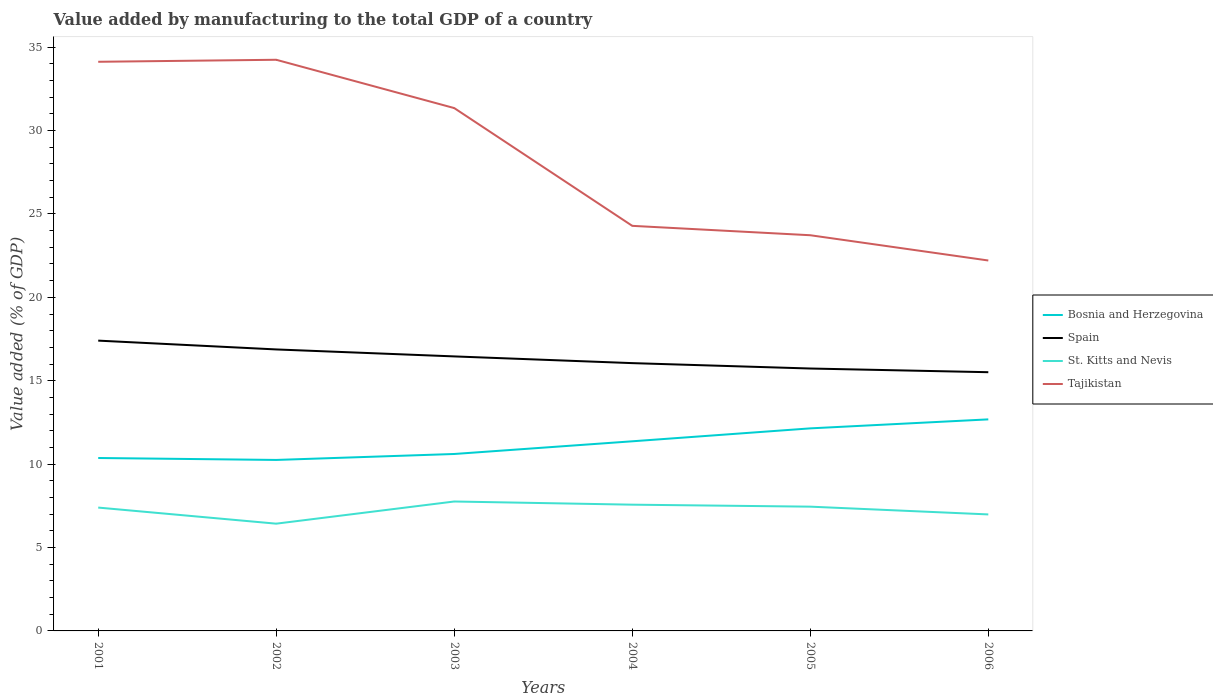Does the line corresponding to Bosnia and Herzegovina intersect with the line corresponding to St. Kitts and Nevis?
Ensure brevity in your answer.  No. Across all years, what is the maximum value added by manufacturing to the total GDP in Tajikistan?
Provide a succinct answer. 22.21. In which year was the value added by manufacturing to the total GDP in Spain maximum?
Offer a very short reply. 2006. What is the total value added by manufacturing to the total GDP in St. Kitts and Nevis in the graph?
Provide a succinct answer. 0.77. What is the difference between the highest and the second highest value added by manufacturing to the total GDP in Bosnia and Herzegovina?
Offer a terse response. 2.43. How many lines are there?
Your answer should be compact. 4. How many years are there in the graph?
Give a very brief answer. 6. Does the graph contain grids?
Offer a terse response. No. How many legend labels are there?
Provide a short and direct response. 4. What is the title of the graph?
Offer a very short reply. Value added by manufacturing to the total GDP of a country. What is the label or title of the Y-axis?
Your response must be concise. Value added (% of GDP). What is the Value added (% of GDP) of Bosnia and Herzegovina in 2001?
Offer a very short reply. 10.37. What is the Value added (% of GDP) in Spain in 2001?
Give a very brief answer. 17.41. What is the Value added (% of GDP) of St. Kitts and Nevis in 2001?
Provide a succinct answer. 7.4. What is the Value added (% of GDP) of Tajikistan in 2001?
Provide a succinct answer. 34.12. What is the Value added (% of GDP) of Bosnia and Herzegovina in 2002?
Offer a very short reply. 10.25. What is the Value added (% of GDP) in Spain in 2002?
Ensure brevity in your answer.  16.88. What is the Value added (% of GDP) in St. Kitts and Nevis in 2002?
Give a very brief answer. 6.43. What is the Value added (% of GDP) of Tajikistan in 2002?
Ensure brevity in your answer.  34.24. What is the Value added (% of GDP) of Bosnia and Herzegovina in 2003?
Offer a terse response. 10.61. What is the Value added (% of GDP) in Spain in 2003?
Give a very brief answer. 16.46. What is the Value added (% of GDP) in St. Kitts and Nevis in 2003?
Ensure brevity in your answer.  7.76. What is the Value added (% of GDP) in Tajikistan in 2003?
Give a very brief answer. 31.35. What is the Value added (% of GDP) of Bosnia and Herzegovina in 2004?
Offer a terse response. 11.37. What is the Value added (% of GDP) of Spain in 2004?
Provide a succinct answer. 16.06. What is the Value added (% of GDP) of St. Kitts and Nevis in 2004?
Give a very brief answer. 7.57. What is the Value added (% of GDP) of Tajikistan in 2004?
Offer a very short reply. 24.29. What is the Value added (% of GDP) in Bosnia and Herzegovina in 2005?
Offer a very short reply. 12.14. What is the Value added (% of GDP) in Spain in 2005?
Offer a terse response. 15.73. What is the Value added (% of GDP) in St. Kitts and Nevis in 2005?
Provide a succinct answer. 7.45. What is the Value added (% of GDP) in Tajikistan in 2005?
Provide a short and direct response. 23.72. What is the Value added (% of GDP) in Bosnia and Herzegovina in 2006?
Your answer should be compact. 12.68. What is the Value added (% of GDP) of Spain in 2006?
Offer a terse response. 15.51. What is the Value added (% of GDP) of St. Kitts and Nevis in 2006?
Ensure brevity in your answer.  6.99. What is the Value added (% of GDP) of Tajikistan in 2006?
Make the answer very short. 22.21. Across all years, what is the maximum Value added (% of GDP) of Bosnia and Herzegovina?
Offer a terse response. 12.68. Across all years, what is the maximum Value added (% of GDP) of Spain?
Your response must be concise. 17.41. Across all years, what is the maximum Value added (% of GDP) in St. Kitts and Nevis?
Provide a succinct answer. 7.76. Across all years, what is the maximum Value added (% of GDP) of Tajikistan?
Offer a very short reply. 34.24. Across all years, what is the minimum Value added (% of GDP) of Bosnia and Herzegovina?
Provide a succinct answer. 10.25. Across all years, what is the minimum Value added (% of GDP) in Spain?
Your answer should be compact. 15.51. Across all years, what is the minimum Value added (% of GDP) of St. Kitts and Nevis?
Make the answer very short. 6.43. Across all years, what is the minimum Value added (% of GDP) of Tajikistan?
Your answer should be compact. 22.21. What is the total Value added (% of GDP) in Bosnia and Herzegovina in the graph?
Provide a short and direct response. 67.42. What is the total Value added (% of GDP) in Spain in the graph?
Keep it short and to the point. 98.04. What is the total Value added (% of GDP) in St. Kitts and Nevis in the graph?
Give a very brief answer. 43.59. What is the total Value added (% of GDP) of Tajikistan in the graph?
Give a very brief answer. 169.93. What is the difference between the Value added (% of GDP) in Bosnia and Herzegovina in 2001 and that in 2002?
Your answer should be compact. 0.12. What is the difference between the Value added (% of GDP) of Spain in 2001 and that in 2002?
Provide a short and direct response. 0.53. What is the difference between the Value added (% of GDP) in St. Kitts and Nevis in 2001 and that in 2002?
Ensure brevity in your answer.  0.96. What is the difference between the Value added (% of GDP) of Tajikistan in 2001 and that in 2002?
Offer a terse response. -0.12. What is the difference between the Value added (% of GDP) in Bosnia and Herzegovina in 2001 and that in 2003?
Ensure brevity in your answer.  -0.24. What is the difference between the Value added (% of GDP) of Spain in 2001 and that in 2003?
Your answer should be very brief. 0.95. What is the difference between the Value added (% of GDP) of St. Kitts and Nevis in 2001 and that in 2003?
Your answer should be very brief. -0.36. What is the difference between the Value added (% of GDP) in Tajikistan in 2001 and that in 2003?
Offer a terse response. 2.78. What is the difference between the Value added (% of GDP) of Bosnia and Herzegovina in 2001 and that in 2004?
Offer a very short reply. -1. What is the difference between the Value added (% of GDP) of Spain in 2001 and that in 2004?
Your answer should be compact. 1.35. What is the difference between the Value added (% of GDP) in St. Kitts and Nevis in 2001 and that in 2004?
Your answer should be compact. -0.17. What is the difference between the Value added (% of GDP) of Tajikistan in 2001 and that in 2004?
Keep it short and to the point. 9.84. What is the difference between the Value added (% of GDP) of Bosnia and Herzegovina in 2001 and that in 2005?
Your answer should be very brief. -1.78. What is the difference between the Value added (% of GDP) of Spain in 2001 and that in 2005?
Your response must be concise. 1.67. What is the difference between the Value added (% of GDP) of St. Kitts and Nevis in 2001 and that in 2005?
Your answer should be compact. -0.06. What is the difference between the Value added (% of GDP) in Tajikistan in 2001 and that in 2005?
Offer a terse response. 10.4. What is the difference between the Value added (% of GDP) of Bosnia and Herzegovina in 2001 and that in 2006?
Ensure brevity in your answer.  -2.32. What is the difference between the Value added (% of GDP) in Spain in 2001 and that in 2006?
Offer a terse response. 1.89. What is the difference between the Value added (% of GDP) in St. Kitts and Nevis in 2001 and that in 2006?
Offer a terse response. 0.41. What is the difference between the Value added (% of GDP) in Tajikistan in 2001 and that in 2006?
Offer a terse response. 11.91. What is the difference between the Value added (% of GDP) in Bosnia and Herzegovina in 2002 and that in 2003?
Your response must be concise. -0.36. What is the difference between the Value added (% of GDP) in Spain in 2002 and that in 2003?
Your answer should be very brief. 0.42. What is the difference between the Value added (% of GDP) in St. Kitts and Nevis in 2002 and that in 2003?
Offer a very short reply. -1.33. What is the difference between the Value added (% of GDP) in Tajikistan in 2002 and that in 2003?
Your answer should be very brief. 2.9. What is the difference between the Value added (% of GDP) in Bosnia and Herzegovina in 2002 and that in 2004?
Offer a very short reply. -1.12. What is the difference between the Value added (% of GDP) in Spain in 2002 and that in 2004?
Your response must be concise. 0.82. What is the difference between the Value added (% of GDP) in St. Kitts and Nevis in 2002 and that in 2004?
Make the answer very short. -1.14. What is the difference between the Value added (% of GDP) of Tajikistan in 2002 and that in 2004?
Offer a very short reply. 9.96. What is the difference between the Value added (% of GDP) of Bosnia and Herzegovina in 2002 and that in 2005?
Keep it short and to the point. -1.89. What is the difference between the Value added (% of GDP) of Spain in 2002 and that in 2005?
Your answer should be compact. 1.14. What is the difference between the Value added (% of GDP) in St. Kitts and Nevis in 2002 and that in 2005?
Offer a terse response. -1.02. What is the difference between the Value added (% of GDP) in Tajikistan in 2002 and that in 2005?
Make the answer very short. 10.52. What is the difference between the Value added (% of GDP) in Bosnia and Herzegovina in 2002 and that in 2006?
Offer a terse response. -2.43. What is the difference between the Value added (% of GDP) of Spain in 2002 and that in 2006?
Offer a terse response. 1.36. What is the difference between the Value added (% of GDP) in St. Kitts and Nevis in 2002 and that in 2006?
Ensure brevity in your answer.  -0.55. What is the difference between the Value added (% of GDP) of Tajikistan in 2002 and that in 2006?
Offer a very short reply. 12.04. What is the difference between the Value added (% of GDP) of Bosnia and Herzegovina in 2003 and that in 2004?
Your response must be concise. -0.76. What is the difference between the Value added (% of GDP) in Spain in 2003 and that in 2004?
Provide a short and direct response. 0.4. What is the difference between the Value added (% of GDP) of St. Kitts and Nevis in 2003 and that in 2004?
Give a very brief answer. 0.19. What is the difference between the Value added (% of GDP) in Tajikistan in 2003 and that in 2004?
Provide a succinct answer. 7.06. What is the difference between the Value added (% of GDP) in Bosnia and Herzegovina in 2003 and that in 2005?
Your answer should be compact. -1.54. What is the difference between the Value added (% of GDP) of Spain in 2003 and that in 2005?
Make the answer very short. 0.73. What is the difference between the Value added (% of GDP) in St. Kitts and Nevis in 2003 and that in 2005?
Offer a very short reply. 0.31. What is the difference between the Value added (% of GDP) of Tajikistan in 2003 and that in 2005?
Your response must be concise. 7.62. What is the difference between the Value added (% of GDP) of Bosnia and Herzegovina in 2003 and that in 2006?
Keep it short and to the point. -2.07. What is the difference between the Value added (% of GDP) in Spain in 2003 and that in 2006?
Keep it short and to the point. 0.95. What is the difference between the Value added (% of GDP) in St. Kitts and Nevis in 2003 and that in 2006?
Offer a terse response. 0.77. What is the difference between the Value added (% of GDP) in Tajikistan in 2003 and that in 2006?
Offer a terse response. 9.14. What is the difference between the Value added (% of GDP) in Bosnia and Herzegovina in 2004 and that in 2005?
Offer a very short reply. -0.78. What is the difference between the Value added (% of GDP) in Spain in 2004 and that in 2005?
Your answer should be very brief. 0.32. What is the difference between the Value added (% of GDP) of St. Kitts and Nevis in 2004 and that in 2005?
Ensure brevity in your answer.  0.12. What is the difference between the Value added (% of GDP) in Tajikistan in 2004 and that in 2005?
Offer a terse response. 0.56. What is the difference between the Value added (% of GDP) in Bosnia and Herzegovina in 2004 and that in 2006?
Provide a succinct answer. -1.31. What is the difference between the Value added (% of GDP) in Spain in 2004 and that in 2006?
Your answer should be compact. 0.54. What is the difference between the Value added (% of GDP) of St. Kitts and Nevis in 2004 and that in 2006?
Make the answer very short. 0.58. What is the difference between the Value added (% of GDP) of Tajikistan in 2004 and that in 2006?
Make the answer very short. 2.08. What is the difference between the Value added (% of GDP) in Bosnia and Herzegovina in 2005 and that in 2006?
Make the answer very short. -0.54. What is the difference between the Value added (% of GDP) in Spain in 2005 and that in 2006?
Your response must be concise. 0.22. What is the difference between the Value added (% of GDP) of St. Kitts and Nevis in 2005 and that in 2006?
Your answer should be very brief. 0.47. What is the difference between the Value added (% of GDP) in Tajikistan in 2005 and that in 2006?
Offer a terse response. 1.51. What is the difference between the Value added (% of GDP) in Bosnia and Herzegovina in 2001 and the Value added (% of GDP) in Spain in 2002?
Ensure brevity in your answer.  -6.51. What is the difference between the Value added (% of GDP) of Bosnia and Herzegovina in 2001 and the Value added (% of GDP) of St. Kitts and Nevis in 2002?
Your answer should be compact. 3.94. What is the difference between the Value added (% of GDP) of Bosnia and Herzegovina in 2001 and the Value added (% of GDP) of Tajikistan in 2002?
Provide a short and direct response. -23.88. What is the difference between the Value added (% of GDP) of Spain in 2001 and the Value added (% of GDP) of St. Kitts and Nevis in 2002?
Your response must be concise. 10.98. What is the difference between the Value added (% of GDP) of Spain in 2001 and the Value added (% of GDP) of Tajikistan in 2002?
Make the answer very short. -16.84. What is the difference between the Value added (% of GDP) of St. Kitts and Nevis in 2001 and the Value added (% of GDP) of Tajikistan in 2002?
Your response must be concise. -26.85. What is the difference between the Value added (% of GDP) in Bosnia and Herzegovina in 2001 and the Value added (% of GDP) in Spain in 2003?
Your answer should be compact. -6.09. What is the difference between the Value added (% of GDP) in Bosnia and Herzegovina in 2001 and the Value added (% of GDP) in St. Kitts and Nevis in 2003?
Your answer should be compact. 2.61. What is the difference between the Value added (% of GDP) of Bosnia and Herzegovina in 2001 and the Value added (% of GDP) of Tajikistan in 2003?
Offer a very short reply. -20.98. What is the difference between the Value added (% of GDP) of Spain in 2001 and the Value added (% of GDP) of St. Kitts and Nevis in 2003?
Keep it short and to the point. 9.65. What is the difference between the Value added (% of GDP) of Spain in 2001 and the Value added (% of GDP) of Tajikistan in 2003?
Provide a succinct answer. -13.94. What is the difference between the Value added (% of GDP) in St. Kitts and Nevis in 2001 and the Value added (% of GDP) in Tajikistan in 2003?
Keep it short and to the point. -23.95. What is the difference between the Value added (% of GDP) in Bosnia and Herzegovina in 2001 and the Value added (% of GDP) in Spain in 2004?
Provide a short and direct response. -5.69. What is the difference between the Value added (% of GDP) in Bosnia and Herzegovina in 2001 and the Value added (% of GDP) in St. Kitts and Nevis in 2004?
Offer a very short reply. 2.8. What is the difference between the Value added (% of GDP) of Bosnia and Herzegovina in 2001 and the Value added (% of GDP) of Tajikistan in 2004?
Provide a short and direct response. -13.92. What is the difference between the Value added (% of GDP) in Spain in 2001 and the Value added (% of GDP) in St. Kitts and Nevis in 2004?
Provide a succinct answer. 9.84. What is the difference between the Value added (% of GDP) of Spain in 2001 and the Value added (% of GDP) of Tajikistan in 2004?
Give a very brief answer. -6.88. What is the difference between the Value added (% of GDP) in St. Kitts and Nevis in 2001 and the Value added (% of GDP) in Tajikistan in 2004?
Your response must be concise. -16.89. What is the difference between the Value added (% of GDP) in Bosnia and Herzegovina in 2001 and the Value added (% of GDP) in Spain in 2005?
Offer a very short reply. -5.36. What is the difference between the Value added (% of GDP) in Bosnia and Herzegovina in 2001 and the Value added (% of GDP) in St. Kitts and Nevis in 2005?
Offer a very short reply. 2.92. What is the difference between the Value added (% of GDP) in Bosnia and Herzegovina in 2001 and the Value added (% of GDP) in Tajikistan in 2005?
Your answer should be compact. -13.36. What is the difference between the Value added (% of GDP) in Spain in 2001 and the Value added (% of GDP) in St. Kitts and Nevis in 2005?
Your response must be concise. 9.96. What is the difference between the Value added (% of GDP) of Spain in 2001 and the Value added (% of GDP) of Tajikistan in 2005?
Give a very brief answer. -6.32. What is the difference between the Value added (% of GDP) in St. Kitts and Nevis in 2001 and the Value added (% of GDP) in Tajikistan in 2005?
Provide a short and direct response. -16.33. What is the difference between the Value added (% of GDP) of Bosnia and Herzegovina in 2001 and the Value added (% of GDP) of Spain in 2006?
Offer a terse response. -5.14. What is the difference between the Value added (% of GDP) of Bosnia and Herzegovina in 2001 and the Value added (% of GDP) of St. Kitts and Nevis in 2006?
Provide a succinct answer. 3.38. What is the difference between the Value added (% of GDP) in Bosnia and Herzegovina in 2001 and the Value added (% of GDP) in Tajikistan in 2006?
Provide a succinct answer. -11.84. What is the difference between the Value added (% of GDP) in Spain in 2001 and the Value added (% of GDP) in St. Kitts and Nevis in 2006?
Your response must be concise. 10.42. What is the difference between the Value added (% of GDP) in Spain in 2001 and the Value added (% of GDP) in Tajikistan in 2006?
Your answer should be compact. -4.8. What is the difference between the Value added (% of GDP) in St. Kitts and Nevis in 2001 and the Value added (% of GDP) in Tajikistan in 2006?
Offer a terse response. -14.81. What is the difference between the Value added (% of GDP) in Bosnia and Herzegovina in 2002 and the Value added (% of GDP) in Spain in 2003?
Ensure brevity in your answer.  -6.21. What is the difference between the Value added (% of GDP) in Bosnia and Herzegovina in 2002 and the Value added (% of GDP) in St. Kitts and Nevis in 2003?
Provide a succinct answer. 2.49. What is the difference between the Value added (% of GDP) of Bosnia and Herzegovina in 2002 and the Value added (% of GDP) of Tajikistan in 2003?
Your response must be concise. -21.1. What is the difference between the Value added (% of GDP) of Spain in 2002 and the Value added (% of GDP) of St. Kitts and Nevis in 2003?
Provide a succinct answer. 9.12. What is the difference between the Value added (% of GDP) of Spain in 2002 and the Value added (% of GDP) of Tajikistan in 2003?
Your response must be concise. -14.47. What is the difference between the Value added (% of GDP) of St. Kitts and Nevis in 2002 and the Value added (% of GDP) of Tajikistan in 2003?
Offer a very short reply. -24.92. What is the difference between the Value added (% of GDP) of Bosnia and Herzegovina in 2002 and the Value added (% of GDP) of Spain in 2004?
Provide a short and direct response. -5.8. What is the difference between the Value added (% of GDP) of Bosnia and Herzegovina in 2002 and the Value added (% of GDP) of St. Kitts and Nevis in 2004?
Offer a very short reply. 2.68. What is the difference between the Value added (% of GDP) in Bosnia and Herzegovina in 2002 and the Value added (% of GDP) in Tajikistan in 2004?
Offer a terse response. -14.04. What is the difference between the Value added (% of GDP) of Spain in 2002 and the Value added (% of GDP) of St. Kitts and Nevis in 2004?
Keep it short and to the point. 9.31. What is the difference between the Value added (% of GDP) of Spain in 2002 and the Value added (% of GDP) of Tajikistan in 2004?
Offer a very short reply. -7.41. What is the difference between the Value added (% of GDP) of St. Kitts and Nevis in 2002 and the Value added (% of GDP) of Tajikistan in 2004?
Provide a succinct answer. -17.86. What is the difference between the Value added (% of GDP) of Bosnia and Herzegovina in 2002 and the Value added (% of GDP) of Spain in 2005?
Give a very brief answer. -5.48. What is the difference between the Value added (% of GDP) of Bosnia and Herzegovina in 2002 and the Value added (% of GDP) of St. Kitts and Nevis in 2005?
Your answer should be very brief. 2.8. What is the difference between the Value added (% of GDP) in Bosnia and Herzegovina in 2002 and the Value added (% of GDP) in Tajikistan in 2005?
Provide a short and direct response. -13.47. What is the difference between the Value added (% of GDP) of Spain in 2002 and the Value added (% of GDP) of St. Kitts and Nevis in 2005?
Ensure brevity in your answer.  9.43. What is the difference between the Value added (% of GDP) in Spain in 2002 and the Value added (% of GDP) in Tajikistan in 2005?
Provide a short and direct response. -6.85. What is the difference between the Value added (% of GDP) in St. Kitts and Nevis in 2002 and the Value added (% of GDP) in Tajikistan in 2005?
Offer a very short reply. -17.29. What is the difference between the Value added (% of GDP) in Bosnia and Herzegovina in 2002 and the Value added (% of GDP) in Spain in 2006?
Your response must be concise. -5.26. What is the difference between the Value added (% of GDP) of Bosnia and Herzegovina in 2002 and the Value added (% of GDP) of St. Kitts and Nevis in 2006?
Your answer should be compact. 3.27. What is the difference between the Value added (% of GDP) in Bosnia and Herzegovina in 2002 and the Value added (% of GDP) in Tajikistan in 2006?
Your answer should be very brief. -11.96. What is the difference between the Value added (% of GDP) in Spain in 2002 and the Value added (% of GDP) in St. Kitts and Nevis in 2006?
Give a very brief answer. 9.89. What is the difference between the Value added (% of GDP) of Spain in 2002 and the Value added (% of GDP) of Tajikistan in 2006?
Give a very brief answer. -5.33. What is the difference between the Value added (% of GDP) of St. Kitts and Nevis in 2002 and the Value added (% of GDP) of Tajikistan in 2006?
Your answer should be very brief. -15.78. What is the difference between the Value added (% of GDP) in Bosnia and Herzegovina in 2003 and the Value added (% of GDP) in Spain in 2004?
Your answer should be compact. -5.45. What is the difference between the Value added (% of GDP) of Bosnia and Herzegovina in 2003 and the Value added (% of GDP) of St. Kitts and Nevis in 2004?
Offer a terse response. 3.04. What is the difference between the Value added (% of GDP) of Bosnia and Herzegovina in 2003 and the Value added (% of GDP) of Tajikistan in 2004?
Keep it short and to the point. -13.68. What is the difference between the Value added (% of GDP) in Spain in 2003 and the Value added (% of GDP) in St. Kitts and Nevis in 2004?
Your response must be concise. 8.89. What is the difference between the Value added (% of GDP) in Spain in 2003 and the Value added (% of GDP) in Tajikistan in 2004?
Keep it short and to the point. -7.83. What is the difference between the Value added (% of GDP) in St. Kitts and Nevis in 2003 and the Value added (% of GDP) in Tajikistan in 2004?
Your answer should be compact. -16.53. What is the difference between the Value added (% of GDP) of Bosnia and Herzegovina in 2003 and the Value added (% of GDP) of Spain in 2005?
Your answer should be very brief. -5.12. What is the difference between the Value added (% of GDP) of Bosnia and Herzegovina in 2003 and the Value added (% of GDP) of St. Kitts and Nevis in 2005?
Your answer should be compact. 3.16. What is the difference between the Value added (% of GDP) in Bosnia and Herzegovina in 2003 and the Value added (% of GDP) in Tajikistan in 2005?
Your answer should be very brief. -13.12. What is the difference between the Value added (% of GDP) of Spain in 2003 and the Value added (% of GDP) of St. Kitts and Nevis in 2005?
Provide a succinct answer. 9.01. What is the difference between the Value added (% of GDP) of Spain in 2003 and the Value added (% of GDP) of Tajikistan in 2005?
Ensure brevity in your answer.  -7.27. What is the difference between the Value added (% of GDP) in St. Kitts and Nevis in 2003 and the Value added (% of GDP) in Tajikistan in 2005?
Provide a short and direct response. -15.96. What is the difference between the Value added (% of GDP) of Bosnia and Herzegovina in 2003 and the Value added (% of GDP) of Spain in 2006?
Your answer should be compact. -4.9. What is the difference between the Value added (% of GDP) of Bosnia and Herzegovina in 2003 and the Value added (% of GDP) of St. Kitts and Nevis in 2006?
Offer a terse response. 3.62. What is the difference between the Value added (% of GDP) in Bosnia and Herzegovina in 2003 and the Value added (% of GDP) in Tajikistan in 2006?
Offer a very short reply. -11.6. What is the difference between the Value added (% of GDP) of Spain in 2003 and the Value added (% of GDP) of St. Kitts and Nevis in 2006?
Your response must be concise. 9.47. What is the difference between the Value added (% of GDP) in Spain in 2003 and the Value added (% of GDP) in Tajikistan in 2006?
Offer a very short reply. -5.75. What is the difference between the Value added (% of GDP) of St. Kitts and Nevis in 2003 and the Value added (% of GDP) of Tajikistan in 2006?
Offer a terse response. -14.45. What is the difference between the Value added (% of GDP) of Bosnia and Herzegovina in 2004 and the Value added (% of GDP) of Spain in 2005?
Your answer should be very brief. -4.36. What is the difference between the Value added (% of GDP) in Bosnia and Herzegovina in 2004 and the Value added (% of GDP) in St. Kitts and Nevis in 2005?
Your answer should be compact. 3.92. What is the difference between the Value added (% of GDP) of Bosnia and Herzegovina in 2004 and the Value added (% of GDP) of Tajikistan in 2005?
Keep it short and to the point. -12.35. What is the difference between the Value added (% of GDP) in Spain in 2004 and the Value added (% of GDP) in St. Kitts and Nevis in 2005?
Provide a succinct answer. 8.61. What is the difference between the Value added (% of GDP) in Spain in 2004 and the Value added (% of GDP) in Tajikistan in 2005?
Provide a succinct answer. -7.67. What is the difference between the Value added (% of GDP) of St. Kitts and Nevis in 2004 and the Value added (% of GDP) of Tajikistan in 2005?
Your response must be concise. -16.15. What is the difference between the Value added (% of GDP) in Bosnia and Herzegovina in 2004 and the Value added (% of GDP) in Spain in 2006?
Keep it short and to the point. -4.14. What is the difference between the Value added (% of GDP) of Bosnia and Herzegovina in 2004 and the Value added (% of GDP) of St. Kitts and Nevis in 2006?
Provide a succinct answer. 4.38. What is the difference between the Value added (% of GDP) in Bosnia and Herzegovina in 2004 and the Value added (% of GDP) in Tajikistan in 2006?
Ensure brevity in your answer.  -10.84. What is the difference between the Value added (% of GDP) of Spain in 2004 and the Value added (% of GDP) of St. Kitts and Nevis in 2006?
Your answer should be compact. 9.07. What is the difference between the Value added (% of GDP) of Spain in 2004 and the Value added (% of GDP) of Tajikistan in 2006?
Give a very brief answer. -6.15. What is the difference between the Value added (% of GDP) of St. Kitts and Nevis in 2004 and the Value added (% of GDP) of Tajikistan in 2006?
Offer a very short reply. -14.64. What is the difference between the Value added (% of GDP) of Bosnia and Herzegovina in 2005 and the Value added (% of GDP) of Spain in 2006?
Keep it short and to the point. -3.37. What is the difference between the Value added (% of GDP) in Bosnia and Herzegovina in 2005 and the Value added (% of GDP) in St. Kitts and Nevis in 2006?
Your response must be concise. 5.16. What is the difference between the Value added (% of GDP) in Bosnia and Herzegovina in 2005 and the Value added (% of GDP) in Tajikistan in 2006?
Your answer should be compact. -10.06. What is the difference between the Value added (% of GDP) of Spain in 2005 and the Value added (% of GDP) of St. Kitts and Nevis in 2006?
Make the answer very short. 8.75. What is the difference between the Value added (% of GDP) in Spain in 2005 and the Value added (% of GDP) in Tajikistan in 2006?
Provide a short and direct response. -6.48. What is the difference between the Value added (% of GDP) in St. Kitts and Nevis in 2005 and the Value added (% of GDP) in Tajikistan in 2006?
Your answer should be very brief. -14.76. What is the average Value added (% of GDP) in Bosnia and Herzegovina per year?
Keep it short and to the point. 11.24. What is the average Value added (% of GDP) of Spain per year?
Make the answer very short. 16.34. What is the average Value added (% of GDP) in St. Kitts and Nevis per year?
Your response must be concise. 7.27. What is the average Value added (% of GDP) of Tajikistan per year?
Ensure brevity in your answer.  28.32. In the year 2001, what is the difference between the Value added (% of GDP) of Bosnia and Herzegovina and Value added (% of GDP) of Spain?
Ensure brevity in your answer.  -7.04. In the year 2001, what is the difference between the Value added (% of GDP) in Bosnia and Herzegovina and Value added (% of GDP) in St. Kitts and Nevis?
Offer a very short reply. 2.97. In the year 2001, what is the difference between the Value added (% of GDP) of Bosnia and Herzegovina and Value added (% of GDP) of Tajikistan?
Your answer should be very brief. -23.76. In the year 2001, what is the difference between the Value added (% of GDP) of Spain and Value added (% of GDP) of St. Kitts and Nevis?
Make the answer very short. 10.01. In the year 2001, what is the difference between the Value added (% of GDP) in Spain and Value added (% of GDP) in Tajikistan?
Your answer should be very brief. -16.72. In the year 2001, what is the difference between the Value added (% of GDP) of St. Kitts and Nevis and Value added (% of GDP) of Tajikistan?
Offer a terse response. -26.73. In the year 2002, what is the difference between the Value added (% of GDP) in Bosnia and Herzegovina and Value added (% of GDP) in Spain?
Ensure brevity in your answer.  -6.63. In the year 2002, what is the difference between the Value added (% of GDP) of Bosnia and Herzegovina and Value added (% of GDP) of St. Kitts and Nevis?
Keep it short and to the point. 3.82. In the year 2002, what is the difference between the Value added (% of GDP) in Bosnia and Herzegovina and Value added (% of GDP) in Tajikistan?
Provide a succinct answer. -23.99. In the year 2002, what is the difference between the Value added (% of GDP) of Spain and Value added (% of GDP) of St. Kitts and Nevis?
Provide a short and direct response. 10.45. In the year 2002, what is the difference between the Value added (% of GDP) in Spain and Value added (% of GDP) in Tajikistan?
Ensure brevity in your answer.  -17.37. In the year 2002, what is the difference between the Value added (% of GDP) in St. Kitts and Nevis and Value added (% of GDP) in Tajikistan?
Offer a terse response. -27.81. In the year 2003, what is the difference between the Value added (% of GDP) of Bosnia and Herzegovina and Value added (% of GDP) of Spain?
Provide a succinct answer. -5.85. In the year 2003, what is the difference between the Value added (% of GDP) in Bosnia and Herzegovina and Value added (% of GDP) in St. Kitts and Nevis?
Your response must be concise. 2.85. In the year 2003, what is the difference between the Value added (% of GDP) in Bosnia and Herzegovina and Value added (% of GDP) in Tajikistan?
Your answer should be compact. -20.74. In the year 2003, what is the difference between the Value added (% of GDP) of Spain and Value added (% of GDP) of St. Kitts and Nevis?
Your answer should be very brief. 8.7. In the year 2003, what is the difference between the Value added (% of GDP) of Spain and Value added (% of GDP) of Tajikistan?
Ensure brevity in your answer.  -14.89. In the year 2003, what is the difference between the Value added (% of GDP) in St. Kitts and Nevis and Value added (% of GDP) in Tajikistan?
Provide a short and direct response. -23.59. In the year 2004, what is the difference between the Value added (% of GDP) of Bosnia and Herzegovina and Value added (% of GDP) of Spain?
Offer a terse response. -4.69. In the year 2004, what is the difference between the Value added (% of GDP) in Bosnia and Herzegovina and Value added (% of GDP) in St. Kitts and Nevis?
Your answer should be very brief. 3.8. In the year 2004, what is the difference between the Value added (% of GDP) in Bosnia and Herzegovina and Value added (% of GDP) in Tajikistan?
Offer a very short reply. -12.92. In the year 2004, what is the difference between the Value added (% of GDP) in Spain and Value added (% of GDP) in St. Kitts and Nevis?
Offer a terse response. 8.49. In the year 2004, what is the difference between the Value added (% of GDP) of Spain and Value added (% of GDP) of Tajikistan?
Provide a succinct answer. -8.23. In the year 2004, what is the difference between the Value added (% of GDP) of St. Kitts and Nevis and Value added (% of GDP) of Tajikistan?
Offer a very short reply. -16.72. In the year 2005, what is the difference between the Value added (% of GDP) of Bosnia and Herzegovina and Value added (% of GDP) of Spain?
Provide a short and direct response. -3.59. In the year 2005, what is the difference between the Value added (% of GDP) in Bosnia and Herzegovina and Value added (% of GDP) in St. Kitts and Nevis?
Offer a terse response. 4.69. In the year 2005, what is the difference between the Value added (% of GDP) of Bosnia and Herzegovina and Value added (% of GDP) of Tajikistan?
Your response must be concise. -11.58. In the year 2005, what is the difference between the Value added (% of GDP) of Spain and Value added (% of GDP) of St. Kitts and Nevis?
Your answer should be compact. 8.28. In the year 2005, what is the difference between the Value added (% of GDP) of Spain and Value added (% of GDP) of Tajikistan?
Make the answer very short. -7.99. In the year 2005, what is the difference between the Value added (% of GDP) of St. Kitts and Nevis and Value added (% of GDP) of Tajikistan?
Provide a short and direct response. -16.27. In the year 2006, what is the difference between the Value added (% of GDP) of Bosnia and Herzegovina and Value added (% of GDP) of Spain?
Offer a very short reply. -2.83. In the year 2006, what is the difference between the Value added (% of GDP) in Bosnia and Herzegovina and Value added (% of GDP) in St. Kitts and Nevis?
Offer a terse response. 5.7. In the year 2006, what is the difference between the Value added (% of GDP) of Bosnia and Herzegovina and Value added (% of GDP) of Tajikistan?
Ensure brevity in your answer.  -9.53. In the year 2006, what is the difference between the Value added (% of GDP) in Spain and Value added (% of GDP) in St. Kitts and Nevis?
Ensure brevity in your answer.  8.53. In the year 2006, what is the difference between the Value added (% of GDP) of Spain and Value added (% of GDP) of Tajikistan?
Make the answer very short. -6.7. In the year 2006, what is the difference between the Value added (% of GDP) of St. Kitts and Nevis and Value added (% of GDP) of Tajikistan?
Give a very brief answer. -15.22. What is the ratio of the Value added (% of GDP) in Bosnia and Herzegovina in 2001 to that in 2002?
Offer a very short reply. 1.01. What is the ratio of the Value added (% of GDP) of Spain in 2001 to that in 2002?
Make the answer very short. 1.03. What is the ratio of the Value added (% of GDP) in St. Kitts and Nevis in 2001 to that in 2002?
Your answer should be very brief. 1.15. What is the ratio of the Value added (% of GDP) in Tajikistan in 2001 to that in 2002?
Your answer should be very brief. 1. What is the ratio of the Value added (% of GDP) in Bosnia and Herzegovina in 2001 to that in 2003?
Your response must be concise. 0.98. What is the ratio of the Value added (% of GDP) in Spain in 2001 to that in 2003?
Offer a very short reply. 1.06. What is the ratio of the Value added (% of GDP) in St. Kitts and Nevis in 2001 to that in 2003?
Keep it short and to the point. 0.95. What is the ratio of the Value added (% of GDP) of Tajikistan in 2001 to that in 2003?
Your answer should be very brief. 1.09. What is the ratio of the Value added (% of GDP) of Bosnia and Herzegovina in 2001 to that in 2004?
Make the answer very short. 0.91. What is the ratio of the Value added (% of GDP) in Spain in 2001 to that in 2004?
Keep it short and to the point. 1.08. What is the ratio of the Value added (% of GDP) in St. Kitts and Nevis in 2001 to that in 2004?
Give a very brief answer. 0.98. What is the ratio of the Value added (% of GDP) in Tajikistan in 2001 to that in 2004?
Your response must be concise. 1.41. What is the ratio of the Value added (% of GDP) of Bosnia and Herzegovina in 2001 to that in 2005?
Your response must be concise. 0.85. What is the ratio of the Value added (% of GDP) of Spain in 2001 to that in 2005?
Offer a very short reply. 1.11. What is the ratio of the Value added (% of GDP) of St. Kitts and Nevis in 2001 to that in 2005?
Make the answer very short. 0.99. What is the ratio of the Value added (% of GDP) in Tajikistan in 2001 to that in 2005?
Ensure brevity in your answer.  1.44. What is the ratio of the Value added (% of GDP) in Bosnia and Herzegovina in 2001 to that in 2006?
Ensure brevity in your answer.  0.82. What is the ratio of the Value added (% of GDP) in Spain in 2001 to that in 2006?
Offer a very short reply. 1.12. What is the ratio of the Value added (% of GDP) of St. Kitts and Nevis in 2001 to that in 2006?
Offer a very short reply. 1.06. What is the ratio of the Value added (% of GDP) in Tajikistan in 2001 to that in 2006?
Your answer should be compact. 1.54. What is the ratio of the Value added (% of GDP) in Bosnia and Herzegovina in 2002 to that in 2003?
Offer a terse response. 0.97. What is the ratio of the Value added (% of GDP) of Spain in 2002 to that in 2003?
Offer a terse response. 1.03. What is the ratio of the Value added (% of GDP) in St. Kitts and Nevis in 2002 to that in 2003?
Give a very brief answer. 0.83. What is the ratio of the Value added (% of GDP) of Tajikistan in 2002 to that in 2003?
Your answer should be very brief. 1.09. What is the ratio of the Value added (% of GDP) of Bosnia and Herzegovina in 2002 to that in 2004?
Ensure brevity in your answer.  0.9. What is the ratio of the Value added (% of GDP) in Spain in 2002 to that in 2004?
Provide a short and direct response. 1.05. What is the ratio of the Value added (% of GDP) of St. Kitts and Nevis in 2002 to that in 2004?
Make the answer very short. 0.85. What is the ratio of the Value added (% of GDP) in Tajikistan in 2002 to that in 2004?
Keep it short and to the point. 1.41. What is the ratio of the Value added (% of GDP) of Bosnia and Herzegovina in 2002 to that in 2005?
Give a very brief answer. 0.84. What is the ratio of the Value added (% of GDP) of Spain in 2002 to that in 2005?
Offer a very short reply. 1.07. What is the ratio of the Value added (% of GDP) of St. Kitts and Nevis in 2002 to that in 2005?
Your answer should be compact. 0.86. What is the ratio of the Value added (% of GDP) in Tajikistan in 2002 to that in 2005?
Make the answer very short. 1.44. What is the ratio of the Value added (% of GDP) in Bosnia and Herzegovina in 2002 to that in 2006?
Offer a terse response. 0.81. What is the ratio of the Value added (% of GDP) of Spain in 2002 to that in 2006?
Your answer should be very brief. 1.09. What is the ratio of the Value added (% of GDP) in St. Kitts and Nevis in 2002 to that in 2006?
Offer a terse response. 0.92. What is the ratio of the Value added (% of GDP) of Tajikistan in 2002 to that in 2006?
Your answer should be compact. 1.54. What is the ratio of the Value added (% of GDP) in Bosnia and Herzegovina in 2003 to that in 2004?
Provide a succinct answer. 0.93. What is the ratio of the Value added (% of GDP) in Spain in 2003 to that in 2004?
Offer a very short reply. 1.03. What is the ratio of the Value added (% of GDP) in St. Kitts and Nevis in 2003 to that in 2004?
Provide a succinct answer. 1.03. What is the ratio of the Value added (% of GDP) of Tajikistan in 2003 to that in 2004?
Give a very brief answer. 1.29. What is the ratio of the Value added (% of GDP) of Bosnia and Herzegovina in 2003 to that in 2005?
Offer a very short reply. 0.87. What is the ratio of the Value added (% of GDP) in Spain in 2003 to that in 2005?
Your response must be concise. 1.05. What is the ratio of the Value added (% of GDP) of St. Kitts and Nevis in 2003 to that in 2005?
Make the answer very short. 1.04. What is the ratio of the Value added (% of GDP) in Tajikistan in 2003 to that in 2005?
Provide a succinct answer. 1.32. What is the ratio of the Value added (% of GDP) in Bosnia and Herzegovina in 2003 to that in 2006?
Your answer should be very brief. 0.84. What is the ratio of the Value added (% of GDP) of Spain in 2003 to that in 2006?
Offer a very short reply. 1.06. What is the ratio of the Value added (% of GDP) of St. Kitts and Nevis in 2003 to that in 2006?
Offer a very short reply. 1.11. What is the ratio of the Value added (% of GDP) of Tajikistan in 2003 to that in 2006?
Give a very brief answer. 1.41. What is the ratio of the Value added (% of GDP) of Bosnia and Herzegovina in 2004 to that in 2005?
Make the answer very short. 0.94. What is the ratio of the Value added (% of GDP) in Spain in 2004 to that in 2005?
Your response must be concise. 1.02. What is the ratio of the Value added (% of GDP) in St. Kitts and Nevis in 2004 to that in 2005?
Provide a succinct answer. 1.02. What is the ratio of the Value added (% of GDP) of Tajikistan in 2004 to that in 2005?
Provide a succinct answer. 1.02. What is the ratio of the Value added (% of GDP) in Bosnia and Herzegovina in 2004 to that in 2006?
Make the answer very short. 0.9. What is the ratio of the Value added (% of GDP) in Spain in 2004 to that in 2006?
Make the answer very short. 1.04. What is the ratio of the Value added (% of GDP) of St. Kitts and Nevis in 2004 to that in 2006?
Ensure brevity in your answer.  1.08. What is the ratio of the Value added (% of GDP) of Tajikistan in 2004 to that in 2006?
Offer a very short reply. 1.09. What is the ratio of the Value added (% of GDP) of Bosnia and Herzegovina in 2005 to that in 2006?
Offer a very short reply. 0.96. What is the ratio of the Value added (% of GDP) in Spain in 2005 to that in 2006?
Provide a short and direct response. 1.01. What is the ratio of the Value added (% of GDP) of St. Kitts and Nevis in 2005 to that in 2006?
Your answer should be compact. 1.07. What is the ratio of the Value added (% of GDP) of Tajikistan in 2005 to that in 2006?
Your response must be concise. 1.07. What is the difference between the highest and the second highest Value added (% of GDP) of Bosnia and Herzegovina?
Your answer should be very brief. 0.54. What is the difference between the highest and the second highest Value added (% of GDP) of Spain?
Make the answer very short. 0.53. What is the difference between the highest and the second highest Value added (% of GDP) in St. Kitts and Nevis?
Keep it short and to the point. 0.19. What is the difference between the highest and the second highest Value added (% of GDP) in Tajikistan?
Provide a short and direct response. 0.12. What is the difference between the highest and the lowest Value added (% of GDP) in Bosnia and Herzegovina?
Your answer should be compact. 2.43. What is the difference between the highest and the lowest Value added (% of GDP) in Spain?
Your answer should be compact. 1.89. What is the difference between the highest and the lowest Value added (% of GDP) of St. Kitts and Nevis?
Your answer should be compact. 1.33. What is the difference between the highest and the lowest Value added (% of GDP) in Tajikistan?
Make the answer very short. 12.04. 